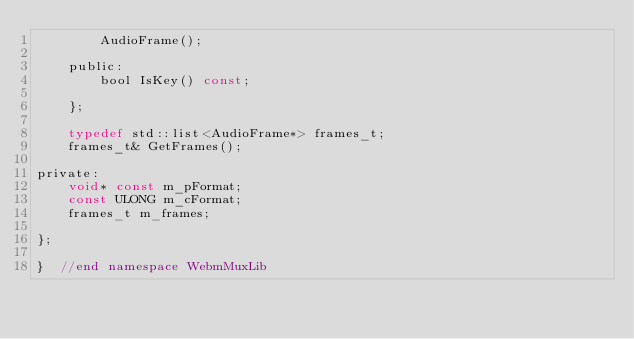<code> <loc_0><loc_0><loc_500><loc_500><_C_>        AudioFrame();

    public:
        bool IsKey() const;

    };

    typedef std::list<AudioFrame*> frames_t;
    frames_t& GetFrames();

private:
    void* const m_pFormat;
    const ULONG m_cFormat;
    frames_t m_frames;

};

}  //end namespace WebmMuxLib
</code> 